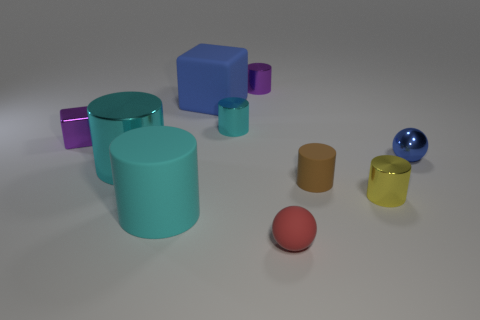Subtract all green blocks. How many cyan cylinders are left? 3 Subtract all large metallic cylinders. How many cylinders are left? 5 Subtract all brown cylinders. How many cylinders are left? 5 Subtract all red balls. Subtract all brown cylinders. How many balls are left? 1 Subtract all cylinders. How many objects are left? 4 Add 4 matte things. How many matte things are left? 8 Add 9 big gray metal cylinders. How many big gray metal cylinders exist? 9 Subtract 0 gray cubes. How many objects are left? 10 Subtract all large yellow cylinders. Subtract all small cyan cylinders. How many objects are left? 9 